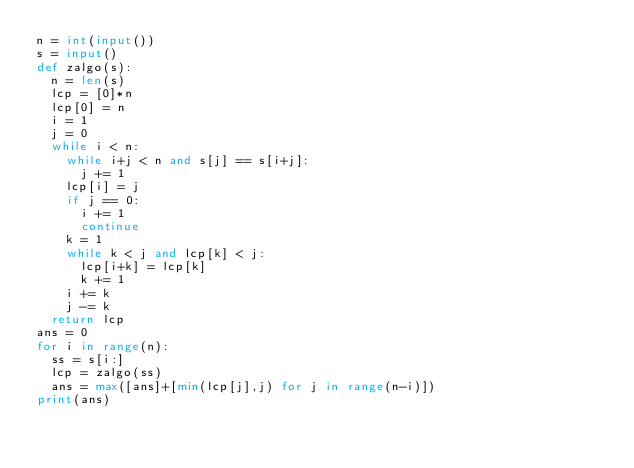<code> <loc_0><loc_0><loc_500><loc_500><_Python_>n = int(input())
s = input()
def zalgo(s):
  n = len(s)
  lcp = [0]*n
  lcp[0] = n
  i = 1
  j = 0
  while i < n:
    while i+j < n and s[j] == s[i+j]:
      j += 1
    lcp[i] = j
    if j == 0:
      i += 1
      continue
    k = 1
    while k < j and lcp[k] < j:
      lcp[i+k] = lcp[k]
      k += 1
    i += k
    j -= k
  return lcp
ans = 0
for i in range(n):
  ss = s[i:]
  lcp = zalgo(ss)
  ans = max([ans]+[min(lcp[j],j) for j in range(n-i)])
print(ans)</code> 